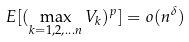Convert formula to latex. <formula><loc_0><loc_0><loc_500><loc_500>E [ ( \max _ { k = 1 , 2 , \dots n } V _ { k } ) ^ { p } ] = o ( n ^ { \delta } )</formula> 